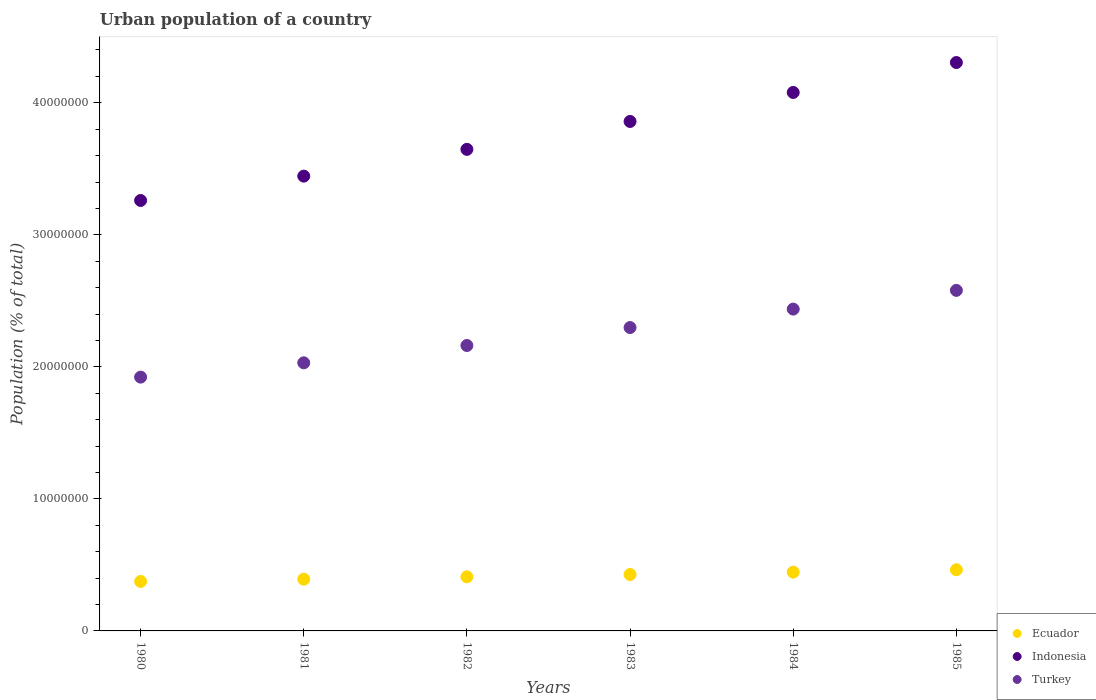What is the urban population in Turkey in 1982?
Provide a succinct answer. 2.16e+07. Across all years, what is the maximum urban population in Turkey?
Provide a succinct answer. 2.58e+07. Across all years, what is the minimum urban population in Ecuador?
Offer a very short reply. 3.75e+06. What is the total urban population in Indonesia in the graph?
Give a very brief answer. 2.26e+08. What is the difference between the urban population in Turkey in 1983 and that in 1984?
Keep it short and to the point. -1.40e+06. What is the difference between the urban population in Turkey in 1985 and the urban population in Ecuador in 1981?
Make the answer very short. 2.19e+07. What is the average urban population in Turkey per year?
Offer a very short reply. 2.24e+07. In the year 1982, what is the difference between the urban population in Turkey and urban population in Ecuador?
Offer a terse response. 1.75e+07. What is the ratio of the urban population in Turkey in 1980 to that in 1982?
Give a very brief answer. 0.89. What is the difference between the highest and the second highest urban population in Turkey?
Make the answer very short. 1.42e+06. What is the difference between the highest and the lowest urban population in Indonesia?
Provide a succinct answer. 1.04e+07. Does the urban population in Ecuador monotonically increase over the years?
Keep it short and to the point. Yes. Is the urban population in Ecuador strictly less than the urban population in Indonesia over the years?
Ensure brevity in your answer.  Yes. How many years are there in the graph?
Keep it short and to the point. 6. Does the graph contain any zero values?
Provide a succinct answer. No. Where does the legend appear in the graph?
Your answer should be very brief. Bottom right. How many legend labels are there?
Make the answer very short. 3. What is the title of the graph?
Your answer should be compact. Urban population of a country. What is the label or title of the X-axis?
Your response must be concise. Years. What is the label or title of the Y-axis?
Offer a terse response. Population (% of total). What is the Population (% of total) in Ecuador in 1980?
Provide a short and direct response. 3.75e+06. What is the Population (% of total) of Indonesia in 1980?
Keep it short and to the point. 3.26e+07. What is the Population (% of total) in Turkey in 1980?
Your answer should be very brief. 1.92e+07. What is the Population (% of total) in Ecuador in 1981?
Your response must be concise. 3.92e+06. What is the Population (% of total) in Indonesia in 1981?
Keep it short and to the point. 3.44e+07. What is the Population (% of total) in Turkey in 1981?
Provide a short and direct response. 2.03e+07. What is the Population (% of total) of Ecuador in 1982?
Offer a very short reply. 4.10e+06. What is the Population (% of total) of Indonesia in 1982?
Provide a short and direct response. 3.65e+07. What is the Population (% of total) of Turkey in 1982?
Provide a short and direct response. 2.16e+07. What is the Population (% of total) in Ecuador in 1983?
Your response must be concise. 4.27e+06. What is the Population (% of total) of Indonesia in 1983?
Your answer should be compact. 3.86e+07. What is the Population (% of total) in Turkey in 1983?
Give a very brief answer. 2.30e+07. What is the Population (% of total) of Ecuador in 1984?
Provide a short and direct response. 4.45e+06. What is the Population (% of total) in Indonesia in 1984?
Give a very brief answer. 4.08e+07. What is the Population (% of total) in Turkey in 1984?
Give a very brief answer. 2.44e+07. What is the Population (% of total) in Ecuador in 1985?
Make the answer very short. 4.63e+06. What is the Population (% of total) of Indonesia in 1985?
Offer a terse response. 4.31e+07. What is the Population (% of total) of Turkey in 1985?
Your answer should be very brief. 2.58e+07. Across all years, what is the maximum Population (% of total) in Ecuador?
Ensure brevity in your answer.  4.63e+06. Across all years, what is the maximum Population (% of total) in Indonesia?
Make the answer very short. 4.31e+07. Across all years, what is the maximum Population (% of total) in Turkey?
Give a very brief answer. 2.58e+07. Across all years, what is the minimum Population (% of total) in Ecuador?
Your answer should be very brief. 3.75e+06. Across all years, what is the minimum Population (% of total) in Indonesia?
Your answer should be compact. 3.26e+07. Across all years, what is the minimum Population (% of total) in Turkey?
Keep it short and to the point. 1.92e+07. What is the total Population (% of total) in Ecuador in the graph?
Keep it short and to the point. 2.51e+07. What is the total Population (% of total) of Indonesia in the graph?
Offer a terse response. 2.26e+08. What is the total Population (% of total) of Turkey in the graph?
Keep it short and to the point. 1.34e+08. What is the difference between the Population (% of total) of Ecuador in 1980 and that in 1981?
Give a very brief answer. -1.73e+05. What is the difference between the Population (% of total) of Indonesia in 1980 and that in 1981?
Ensure brevity in your answer.  -1.84e+06. What is the difference between the Population (% of total) of Turkey in 1980 and that in 1981?
Your answer should be compact. -1.08e+06. What is the difference between the Population (% of total) in Ecuador in 1980 and that in 1982?
Make the answer very short. -3.51e+05. What is the difference between the Population (% of total) in Indonesia in 1980 and that in 1982?
Offer a terse response. -3.87e+06. What is the difference between the Population (% of total) of Turkey in 1980 and that in 1982?
Offer a terse response. -2.40e+06. What is the difference between the Population (% of total) of Ecuador in 1980 and that in 1983?
Your answer should be compact. -5.28e+05. What is the difference between the Population (% of total) in Indonesia in 1980 and that in 1983?
Keep it short and to the point. -5.99e+06. What is the difference between the Population (% of total) in Turkey in 1980 and that in 1983?
Give a very brief answer. -3.76e+06. What is the difference between the Population (% of total) in Ecuador in 1980 and that in 1984?
Provide a short and direct response. -7.05e+05. What is the difference between the Population (% of total) in Indonesia in 1980 and that in 1984?
Provide a short and direct response. -8.18e+06. What is the difference between the Population (% of total) in Turkey in 1980 and that in 1984?
Provide a succinct answer. -5.15e+06. What is the difference between the Population (% of total) of Ecuador in 1980 and that in 1985?
Offer a terse response. -8.87e+05. What is the difference between the Population (% of total) of Indonesia in 1980 and that in 1985?
Your answer should be very brief. -1.04e+07. What is the difference between the Population (% of total) in Turkey in 1980 and that in 1985?
Your answer should be compact. -6.57e+06. What is the difference between the Population (% of total) in Ecuador in 1981 and that in 1982?
Provide a short and direct response. -1.78e+05. What is the difference between the Population (% of total) in Indonesia in 1981 and that in 1982?
Your answer should be compact. -2.03e+06. What is the difference between the Population (% of total) in Turkey in 1981 and that in 1982?
Your answer should be compact. -1.31e+06. What is the difference between the Population (% of total) in Ecuador in 1981 and that in 1983?
Make the answer very short. -3.55e+05. What is the difference between the Population (% of total) in Indonesia in 1981 and that in 1983?
Give a very brief answer. -4.14e+06. What is the difference between the Population (% of total) in Turkey in 1981 and that in 1983?
Offer a terse response. -2.67e+06. What is the difference between the Population (% of total) in Ecuador in 1981 and that in 1984?
Make the answer very short. -5.32e+05. What is the difference between the Population (% of total) in Indonesia in 1981 and that in 1984?
Your answer should be compact. -6.34e+06. What is the difference between the Population (% of total) in Turkey in 1981 and that in 1984?
Your response must be concise. -4.07e+06. What is the difference between the Population (% of total) in Ecuador in 1981 and that in 1985?
Make the answer very short. -7.14e+05. What is the difference between the Population (% of total) in Indonesia in 1981 and that in 1985?
Provide a succinct answer. -8.60e+06. What is the difference between the Population (% of total) in Turkey in 1981 and that in 1985?
Make the answer very short. -5.49e+06. What is the difference between the Population (% of total) of Ecuador in 1982 and that in 1983?
Make the answer very short. -1.76e+05. What is the difference between the Population (% of total) in Indonesia in 1982 and that in 1983?
Offer a terse response. -2.11e+06. What is the difference between the Population (% of total) of Turkey in 1982 and that in 1983?
Keep it short and to the point. -1.36e+06. What is the difference between the Population (% of total) of Ecuador in 1982 and that in 1984?
Your answer should be very brief. -3.53e+05. What is the difference between the Population (% of total) of Indonesia in 1982 and that in 1984?
Your answer should be compact. -4.31e+06. What is the difference between the Population (% of total) of Turkey in 1982 and that in 1984?
Offer a terse response. -2.76e+06. What is the difference between the Population (% of total) in Ecuador in 1982 and that in 1985?
Provide a succinct answer. -5.36e+05. What is the difference between the Population (% of total) of Indonesia in 1982 and that in 1985?
Keep it short and to the point. -6.58e+06. What is the difference between the Population (% of total) in Turkey in 1982 and that in 1985?
Give a very brief answer. -4.18e+06. What is the difference between the Population (% of total) in Ecuador in 1983 and that in 1984?
Provide a short and direct response. -1.77e+05. What is the difference between the Population (% of total) of Indonesia in 1983 and that in 1984?
Give a very brief answer. -2.20e+06. What is the difference between the Population (% of total) in Turkey in 1983 and that in 1984?
Your response must be concise. -1.40e+06. What is the difference between the Population (% of total) of Ecuador in 1983 and that in 1985?
Keep it short and to the point. -3.59e+05. What is the difference between the Population (% of total) of Indonesia in 1983 and that in 1985?
Offer a terse response. -4.46e+06. What is the difference between the Population (% of total) of Turkey in 1983 and that in 1985?
Ensure brevity in your answer.  -2.82e+06. What is the difference between the Population (% of total) of Ecuador in 1984 and that in 1985?
Your answer should be compact. -1.82e+05. What is the difference between the Population (% of total) of Indonesia in 1984 and that in 1985?
Your answer should be very brief. -2.27e+06. What is the difference between the Population (% of total) in Turkey in 1984 and that in 1985?
Make the answer very short. -1.42e+06. What is the difference between the Population (% of total) of Ecuador in 1980 and the Population (% of total) of Indonesia in 1981?
Your answer should be very brief. -3.07e+07. What is the difference between the Population (% of total) in Ecuador in 1980 and the Population (% of total) in Turkey in 1981?
Ensure brevity in your answer.  -1.66e+07. What is the difference between the Population (% of total) of Indonesia in 1980 and the Population (% of total) of Turkey in 1981?
Provide a succinct answer. 1.23e+07. What is the difference between the Population (% of total) in Ecuador in 1980 and the Population (% of total) in Indonesia in 1982?
Your answer should be very brief. -3.27e+07. What is the difference between the Population (% of total) of Ecuador in 1980 and the Population (% of total) of Turkey in 1982?
Give a very brief answer. -1.79e+07. What is the difference between the Population (% of total) of Indonesia in 1980 and the Population (% of total) of Turkey in 1982?
Your answer should be compact. 1.10e+07. What is the difference between the Population (% of total) in Ecuador in 1980 and the Population (% of total) in Indonesia in 1983?
Your answer should be very brief. -3.48e+07. What is the difference between the Population (% of total) of Ecuador in 1980 and the Population (% of total) of Turkey in 1983?
Ensure brevity in your answer.  -1.92e+07. What is the difference between the Population (% of total) of Indonesia in 1980 and the Population (% of total) of Turkey in 1983?
Ensure brevity in your answer.  9.62e+06. What is the difference between the Population (% of total) of Ecuador in 1980 and the Population (% of total) of Indonesia in 1984?
Your response must be concise. -3.70e+07. What is the difference between the Population (% of total) in Ecuador in 1980 and the Population (% of total) in Turkey in 1984?
Provide a succinct answer. -2.06e+07. What is the difference between the Population (% of total) of Indonesia in 1980 and the Population (% of total) of Turkey in 1984?
Your answer should be compact. 8.23e+06. What is the difference between the Population (% of total) of Ecuador in 1980 and the Population (% of total) of Indonesia in 1985?
Provide a succinct answer. -3.93e+07. What is the difference between the Population (% of total) of Ecuador in 1980 and the Population (% of total) of Turkey in 1985?
Give a very brief answer. -2.20e+07. What is the difference between the Population (% of total) of Indonesia in 1980 and the Population (% of total) of Turkey in 1985?
Offer a terse response. 6.81e+06. What is the difference between the Population (% of total) in Ecuador in 1981 and the Population (% of total) in Indonesia in 1982?
Provide a succinct answer. -3.26e+07. What is the difference between the Population (% of total) of Ecuador in 1981 and the Population (% of total) of Turkey in 1982?
Your answer should be very brief. -1.77e+07. What is the difference between the Population (% of total) in Indonesia in 1981 and the Population (% of total) in Turkey in 1982?
Your answer should be compact. 1.28e+07. What is the difference between the Population (% of total) of Ecuador in 1981 and the Population (% of total) of Indonesia in 1983?
Offer a very short reply. -3.47e+07. What is the difference between the Population (% of total) in Ecuador in 1981 and the Population (% of total) in Turkey in 1983?
Make the answer very short. -1.91e+07. What is the difference between the Population (% of total) of Indonesia in 1981 and the Population (% of total) of Turkey in 1983?
Offer a terse response. 1.15e+07. What is the difference between the Population (% of total) of Ecuador in 1981 and the Population (% of total) of Indonesia in 1984?
Make the answer very short. -3.69e+07. What is the difference between the Population (% of total) in Ecuador in 1981 and the Population (% of total) in Turkey in 1984?
Your answer should be compact. -2.05e+07. What is the difference between the Population (% of total) of Indonesia in 1981 and the Population (% of total) of Turkey in 1984?
Offer a very short reply. 1.01e+07. What is the difference between the Population (% of total) in Ecuador in 1981 and the Population (% of total) in Indonesia in 1985?
Offer a very short reply. -3.91e+07. What is the difference between the Population (% of total) in Ecuador in 1981 and the Population (% of total) in Turkey in 1985?
Ensure brevity in your answer.  -2.19e+07. What is the difference between the Population (% of total) in Indonesia in 1981 and the Population (% of total) in Turkey in 1985?
Offer a very short reply. 8.65e+06. What is the difference between the Population (% of total) of Ecuador in 1982 and the Population (% of total) of Indonesia in 1983?
Give a very brief answer. -3.45e+07. What is the difference between the Population (% of total) of Ecuador in 1982 and the Population (% of total) of Turkey in 1983?
Offer a terse response. -1.89e+07. What is the difference between the Population (% of total) in Indonesia in 1982 and the Population (% of total) in Turkey in 1983?
Make the answer very short. 1.35e+07. What is the difference between the Population (% of total) of Ecuador in 1982 and the Population (% of total) of Indonesia in 1984?
Your answer should be compact. -3.67e+07. What is the difference between the Population (% of total) in Ecuador in 1982 and the Population (% of total) in Turkey in 1984?
Your answer should be very brief. -2.03e+07. What is the difference between the Population (% of total) in Indonesia in 1982 and the Population (% of total) in Turkey in 1984?
Offer a very short reply. 1.21e+07. What is the difference between the Population (% of total) in Ecuador in 1982 and the Population (% of total) in Indonesia in 1985?
Provide a short and direct response. -3.90e+07. What is the difference between the Population (% of total) of Ecuador in 1982 and the Population (% of total) of Turkey in 1985?
Provide a short and direct response. -2.17e+07. What is the difference between the Population (% of total) of Indonesia in 1982 and the Population (% of total) of Turkey in 1985?
Ensure brevity in your answer.  1.07e+07. What is the difference between the Population (% of total) of Ecuador in 1983 and the Population (% of total) of Indonesia in 1984?
Offer a very short reply. -3.65e+07. What is the difference between the Population (% of total) of Ecuador in 1983 and the Population (% of total) of Turkey in 1984?
Your answer should be compact. -2.01e+07. What is the difference between the Population (% of total) in Indonesia in 1983 and the Population (% of total) in Turkey in 1984?
Offer a terse response. 1.42e+07. What is the difference between the Population (% of total) of Ecuador in 1983 and the Population (% of total) of Indonesia in 1985?
Your answer should be very brief. -3.88e+07. What is the difference between the Population (% of total) of Ecuador in 1983 and the Population (% of total) of Turkey in 1985?
Ensure brevity in your answer.  -2.15e+07. What is the difference between the Population (% of total) of Indonesia in 1983 and the Population (% of total) of Turkey in 1985?
Your answer should be very brief. 1.28e+07. What is the difference between the Population (% of total) in Ecuador in 1984 and the Population (% of total) in Indonesia in 1985?
Offer a very short reply. -3.86e+07. What is the difference between the Population (% of total) of Ecuador in 1984 and the Population (% of total) of Turkey in 1985?
Ensure brevity in your answer.  -2.13e+07. What is the difference between the Population (% of total) in Indonesia in 1984 and the Population (% of total) in Turkey in 1985?
Your response must be concise. 1.50e+07. What is the average Population (% of total) in Ecuador per year?
Your answer should be compact. 4.19e+06. What is the average Population (% of total) in Indonesia per year?
Offer a very short reply. 3.77e+07. What is the average Population (% of total) of Turkey per year?
Give a very brief answer. 2.24e+07. In the year 1980, what is the difference between the Population (% of total) in Ecuador and Population (% of total) in Indonesia?
Offer a very short reply. -2.89e+07. In the year 1980, what is the difference between the Population (% of total) in Ecuador and Population (% of total) in Turkey?
Give a very brief answer. -1.55e+07. In the year 1980, what is the difference between the Population (% of total) in Indonesia and Population (% of total) in Turkey?
Provide a succinct answer. 1.34e+07. In the year 1981, what is the difference between the Population (% of total) in Ecuador and Population (% of total) in Indonesia?
Your answer should be compact. -3.05e+07. In the year 1981, what is the difference between the Population (% of total) in Ecuador and Population (% of total) in Turkey?
Ensure brevity in your answer.  -1.64e+07. In the year 1981, what is the difference between the Population (% of total) in Indonesia and Population (% of total) in Turkey?
Make the answer very short. 1.41e+07. In the year 1982, what is the difference between the Population (% of total) in Ecuador and Population (% of total) in Indonesia?
Keep it short and to the point. -3.24e+07. In the year 1982, what is the difference between the Population (% of total) in Ecuador and Population (% of total) in Turkey?
Provide a succinct answer. -1.75e+07. In the year 1982, what is the difference between the Population (% of total) of Indonesia and Population (% of total) of Turkey?
Ensure brevity in your answer.  1.49e+07. In the year 1983, what is the difference between the Population (% of total) of Ecuador and Population (% of total) of Indonesia?
Your answer should be very brief. -3.43e+07. In the year 1983, what is the difference between the Population (% of total) in Ecuador and Population (% of total) in Turkey?
Provide a short and direct response. -1.87e+07. In the year 1983, what is the difference between the Population (% of total) of Indonesia and Population (% of total) of Turkey?
Offer a terse response. 1.56e+07. In the year 1984, what is the difference between the Population (% of total) in Ecuador and Population (% of total) in Indonesia?
Provide a succinct answer. -3.63e+07. In the year 1984, what is the difference between the Population (% of total) of Ecuador and Population (% of total) of Turkey?
Your answer should be very brief. -1.99e+07. In the year 1984, what is the difference between the Population (% of total) in Indonesia and Population (% of total) in Turkey?
Your answer should be very brief. 1.64e+07. In the year 1985, what is the difference between the Population (% of total) of Ecuador and Population (% of total) of Indonesia?
Provide a short and direct response. -3.84e+07. In the year 1985, what is the difference between the Population (% of total) in Ecuador and Population (% of total) in Turkey?
Your answer should be very brief. -2.12e+07. In the year 1985, what is the difference between the Population (% of total) in Indonesia and Population (% of total) in Turkey?
Your answer should be compact. 1.73e+07. What is the ratio of the Population (% of total) of Ecuador in 1980 to that in 1981?
Your answer should be very brief. 0.96. What is the ratio of the Population (% of total) in Indonesia in 1980 to that in 1981?
Offer a terse response. 0.95. What is the ratio of the Population (% of total) in Turkey in 1980 to that in 1981?
Give a very brief answer. 0.95. What is the ratio of the Population (% of total) in Ecuador in 1980 to that in 1982?
Make the answer very short. 0.91. What is the ratio of the Population (% of total) in Indonesia in 1980 to that in 1982?
Provide a succinct answer. 0.89. What is the ratio of the Population (% of total) of Turkey in 1980 to that in 1982?
Give a very brief answer. 0.89. What is the ratio of the Population (% of total) in Ecuador in 1980 to that in 1983?
Your response must be concise. 0.88. What is the ratio of the Population (% of total) in Indonesia in 1980 to that in 1983?
Keep it short and to the point. 0.84. What is the ratio of the Population (% of total) in Turkey in 1980 to that in 1983?
Your answer should be very brief. 0.84. What is the ratio of the Population (% of total) in Ecuador in 1980 to that in 1984?
Provide a succinct answer. 0.84. What is the ratio of the Population (% of total) in Indonesia in 1980 to that in 1984?
Make the answer very short. 0.8. What is the ratio of the Population (% of total) in Turkey in 1980 to that in 1984?
Offer a very short reply. 0.79. What is the ratio of the Population (% of total) in Ecuador in 1980 to that in 1985?
Give a very brief answer. 0.81. What is the ratio of the Population (% of total) in Indonesia in 1980 to that in 1985?
Offer a terse response. 0.76. What is the ratio of the Population (% of total) in Turkey in 1980 to that in 1985?
Provide a succinct answer. 0.75. What is the ratio of the Population (% of total) in Ecuador in 1981 to that in 1982?
Provide a succinct answer. 0.96. What is the ratio of the Population (% of total) in Indonesia in 1981 to that in 1982?
Your answer should be compact. 0.94. What is the ratio of the Population (% of total) in Turkey in 1981 to that in 1982?
Your answer should be very brief. 0.94. What is the ratio of the Population (% of total) of Ecuador in 1981 to that in 1983?
Your answer should be compact. 0.92. What is the ratio of the Population (% of total) of Indonesia in 1981 to that in 1983?
Keep it short and to the point. 0.89. What is the ratio of the Population (% of total) of Turkey in 1981 to that in 1983?
Offer a terse response. 0.88. What is the ratio of the Population (% of total) in Ecuador in 1981 to that in 1984?
Offer a terse response. 0.88. What is the ratio of the Population (% of total) of Indonesia in 1981 to that in 1984?
Keep it short and to the point. 0.84. What is the ratio of the Population (% of total) of Turkey in 1981 to that in 1984?
Offer a terse response. 0.83. What is the ratio of the Population (% of total) of Ecuador in 1981 to that in 1985?
Your answer should be very brief. 0.85. What is the ratio of the Population (% of total) of Indonesia in 1981 to that in 1985?
Offer a very short reply. 0.8. What is the ratio of the Population (% of total) in Turkey in 1981 to that in 1985?
Make the answer very short. 0.79. What is the ratio of the Population (% of total) in Ecuador in 1982 to that in 1983?
Your answer should be compact. 0.96. What is the ratio of the Population (% of total) in Indonesia in 1982 to that in 1983?
Make the answer very short. 0.95. What is the ratio of the Population (% of total) in Turkey in 1982 to that in 1983?
Provide a succinct answer. 0.94. What is the ratio of the Population (% of total) in Ecuador in 1982 to that in 1984?
Offer a terse response. 0.92. What is the ratio of the Population (% of total) of Indonesia in 1982 to that in 1984?
Your response must be concise. 0.89. What is the ratio of the Population (% of total) of Turkey in 1982 to that in 1984?
Provide a short and direct response. 0.89. What is the ratio of the Population (% of total) of Ecuador in 1982 to that in 1985?
Offer a terse response. 0.88. What is the ratio of the Population (% of total) of Indonesia in 1982 to that in 1985?
Offer a very short reply. 0.85. What is the ratio of the Population (% of total) of Turkey in 1982 to that in 1985?
Ensure brevity in your answer.  0.84. What is the ratio of the Population (% of total) of Ecuador in 1983 to that in 1984?
Offer a very short reply. 0.96. What is the ratio of the Population (% of total) of Indonesia in 1983 to that in 1984?
Make the answer very short. 0.95. What is the ratio of the Population (% of total) in Turkey in 1983 to that in 1984?
Your response must be concise. 0.94. What is the ratio of the Population (% of total) of Ecuador in 1983 to that in 1985?
Your answer should be compact. 0.92. What is the ratio of the Population (% of total) in Indonesia in 1983 to that in 1985?
Offer a very short reply. 0.9. What is the ratio of the Population (% of total) of Turkey in 1983 to that in 1985?
Keep it short and to the point. 0.89. What is the ratio of the Population (% of total) in Ecuador in 1984 to that in 1985?
Your answer should be very brief. 0.96. What is the ratio of the Population (% of total) in Indonesia in 1984 to that in 1985?
Your response must be concise. 0.95. What is the ratio of the Population (% of total) of Turkey in 1984 to that in 1985?
Make the answer very short. 0.94. What is the difference between the highest and the second highest Population (% of total) in Ecuador?
Make the answer very short. 1.82e+05. What is the difference between the highest and the second highest Population (% of total) in Indonesia?
Keep it short and to the point. 2.27e+06. What is the difference between the highest and the second highest Population (% of total) in Turkey?
Make the answer very short. 1.42e+06. What is the difference between the highest and the lowest Population (% of total) in Ecuador?
Keep it short and to the point. 8.87e+05. What is the difference between the highest and the lowest Population (% of total) in Indonesia?
Your response must be concise. 1.04e+07. What is the difference between the highest and the lowest Population (% of total) of Turkey?
Your answer should be very brief. 6.57e+06. 